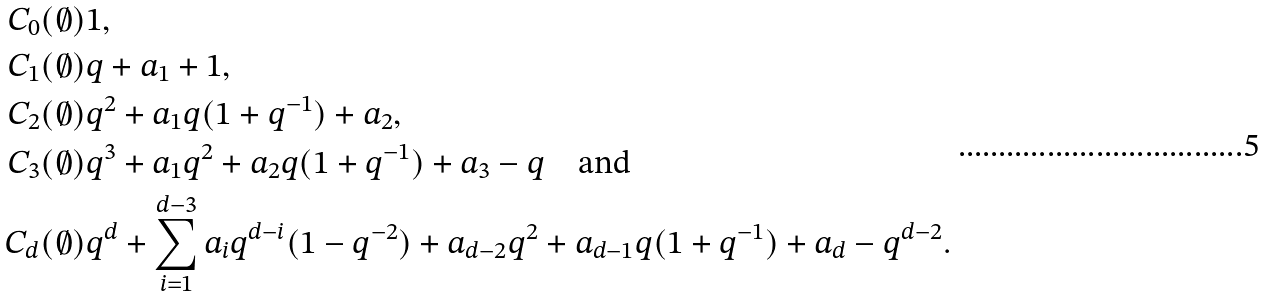Convert formula to latex. <formula><loc_0><loc_0><loc_500><loc_500>C _ { 0 } ( \emptyset ) & 1 , \\ C _ { 1 } ( \emptyset ) & q + a _ { 1 } + 1 , \\ C _ { 2 } ( \emptyset ) & q ^ { 2 } + a _ { 1 } q ( 1 + q ^ { - 1 } ) + a _ { 2 } , \\ C _ { 3 } ( \emptyset ) & q ^ { 3 } + a _ { 1 } q ^ { 2 } + a _ { 2 } q ( 1 + q ^ { - 1 } ) + a _ { 3 } - q \quad \text {and} \\ C _ { d } ( \emptyset ) & q ^ { d } + \sum _ { i = 1 } ^ { d - 3 } a _ { i } q ^ { d - i } ( 1 - q ^ { - 2 } ) + a _ { d - 2 } q ^ { 2 } + a _ { d - 1 } q ( 1 + q ^ { - 1 } ) + a _ { d } - q ^ { d - 2 } .</formula> 